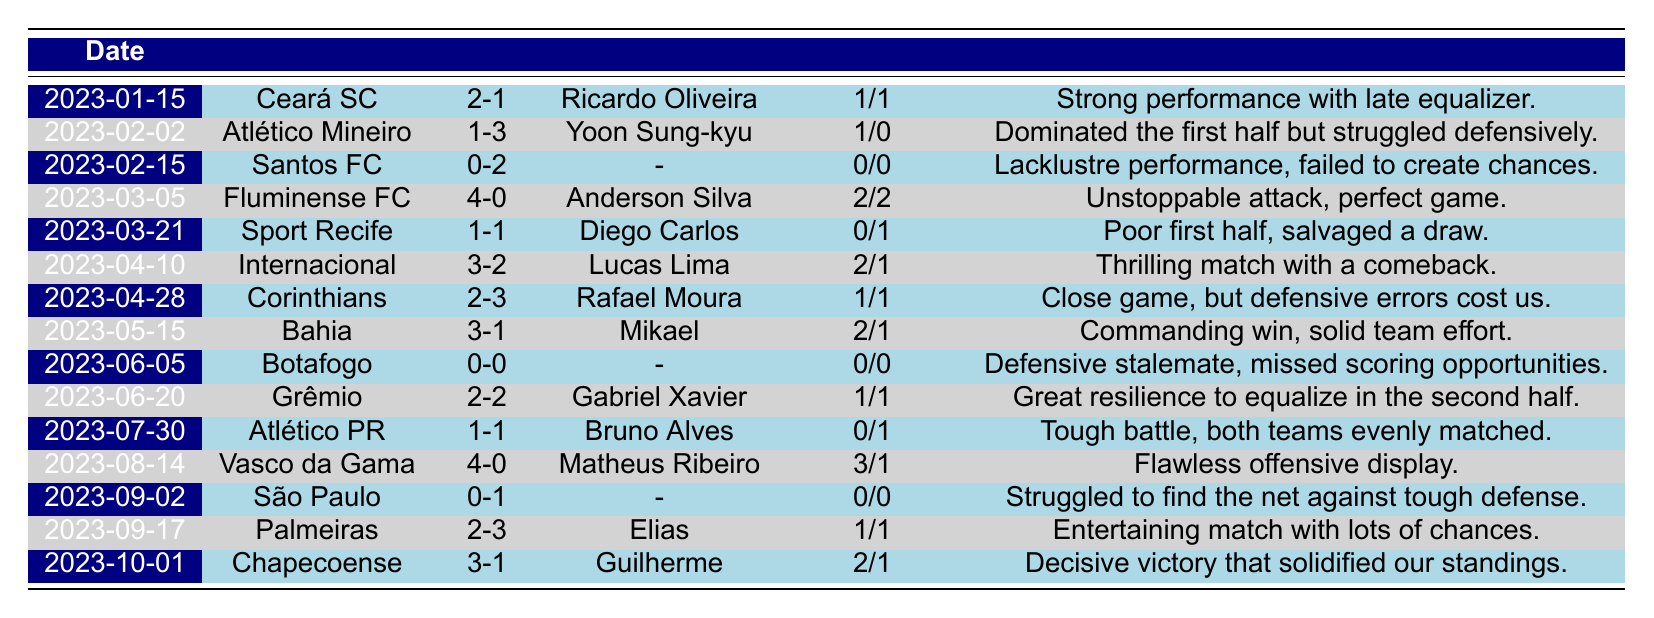What was the score of the match against Ceará SC? The score against Ceará SC, as indicated in the match details, is displayed as 2-1.
Answer: 2-1 Who was the top scorer in the match against Fluminense FC? The top scorer in the match against Fluminense FC is noted as Anderson Silva.
Answer: Anderson Silva How many goals did Náutico score in total during the matches listed? By adding the goals scored in all matches (2 + 1 + 0 + 4 + 1 + 3 + 2 + 3 + 0 + 2 + 1 + 4 + 0 + 2 + 3 + 3), the total comes to 26 goals.
Answer: 26 Did Náutico win all matches against teams they scored 4 goals? In the matches where Náutico scored 4 goals, they played against Fluminense FC (4-0) and Vasco da Gama (4-0), both of which were wins. Therefore, they won all matches where they scored 4 goals.
Answer: Yes What was the average number of goals scored per match across the complete list? The total number of goals scored is 26 from 15 matches. To find the average, divide the total goals (26) by the number of matches (15), resulting in an average of approximately 1.73 goals per match.
Answer: 1.73 Which match had the highest number of goals conceded by Náutico? The match against Corinthians had the highest number of goals conceded, which was 3 goals in a 2-3 loss.
Answer: 3 How many matches ended in a draw? The matches against Sport Recife (1-1), Grêmio (2-2), and Atlético PR (1-1) all ended in draws, totaling 3 matches.
Answer: 3 In which match did Náutico have the most balanced scoring between the first and second halves? The match against Grêmio is the most balanced, scoring 1 goal in the first half and 1 in the second half, making it equally distributed.
Answer: Grêmio What percentage of matches had a top scorer that scored 2 or more goals? The matches that had a top scorer scoring 2 or more goals are against Fluminense FC (4), Internacional (3), Bahia (3), and Chapecoense (3). This counts as 4 matches out of 15, which gives a percentage of (4/15)*100 = 26.67%.
Answer: 26.67% 